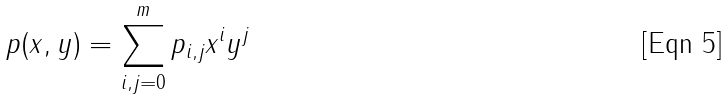<formula> <loc_0><loc_0><loc_500><loc_500>p ( x , y ) = \sum _ { i , j = 0 } ^ { m } p _ { i , j } x ^ { i } y ^ { j }</formula> 